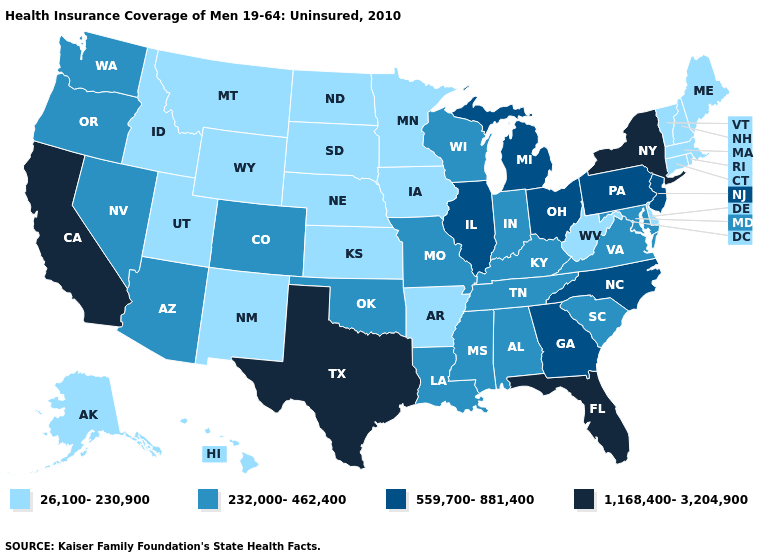Does Utah have the highest value in the West?
Short answer required. No. Which states have the lowest value in the USA?
Give a very brief answer. Alaska, Arkansas, Connecticut, Delaware, Hawaii, Idaho, Iowa, Kansas, Maine, Massachusetts, Minnesota, Montana, Nebraska, New Hampshire, New Mexico, North Dakota, Rhode Island, South Dakota, Utah, Vermont, West Virginia, Wyoming. What is the highest value in the USA?
Quick response, please. 1,168,400-3,204,900. Does the first symbol in the legend represent the smallest category?
Short answer required. Yes. Does Connecticut have the lowest value in the USA?
Answer briefly. Yes. What is the highest value in states that border Ohio?
Write a very short answer. 559,700-881,400. What is the value of New Hampshire?
Keep it brief. 26,100-230,900. What is the value of New Jersey?
Give a very brief answer. 559,700-881,400. Is the legend a continuous bar?
Give a very brief answer. No. Which states have the highest value in the USA?
Concise answer only. California, Florida, New York, Texas. Which states hav the highest value in the West?
Short answer required. California. What is the value of Colorado?
Quick response, please. 232,000-462,400. What is the highest value in the MidWest ?
Give a very brief answer. 559,700-881,400. What is the highest value in the USA?
Answer briefly. 1,168,400-3,204,900. What is the value of Washington?
Short answer required. 232,000-462,400. 